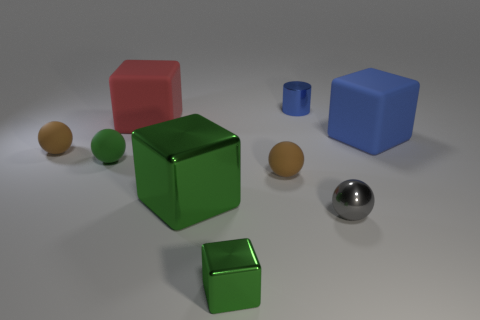What color is the cylinder?
Offer a terse response. Blue. What is the color of the shiny object behind the brown matte object on the left side of the tiny green shiny object?
Offer a terse response. Blue. There is a tiny metal cylinder; is it the same color as the large block right of the big green block?
Keep it short and to the point. Yes. There is a blue thing behind the blue object on the right side of the blue cylinder; how many large green metal cubes are in front of it?
Offer a terse response. 1. Are there any brown balls left of the red object?
Your answer should be very brief. Yes. Are there any other things of the same color as the metal cylinder?
Ensure brevity in your answer.  Yes. What number of cubes are small blue things or small green metal things?
Offer a very short reply. 1. How many tiny shiny things are to the left of the gray shiny ball and in front of the large blue rubber thing?
Offer a terse response. 1. Is the number of small cylinders that are in front of the small metallic ball the same as the number of large blue objects that are in front of the large red rubber cube?
Your response must be concise. No. Is the shape of the large thing that is right of the small green cube the same as  the large red matte thing?
Make the answer very short. Yes. 